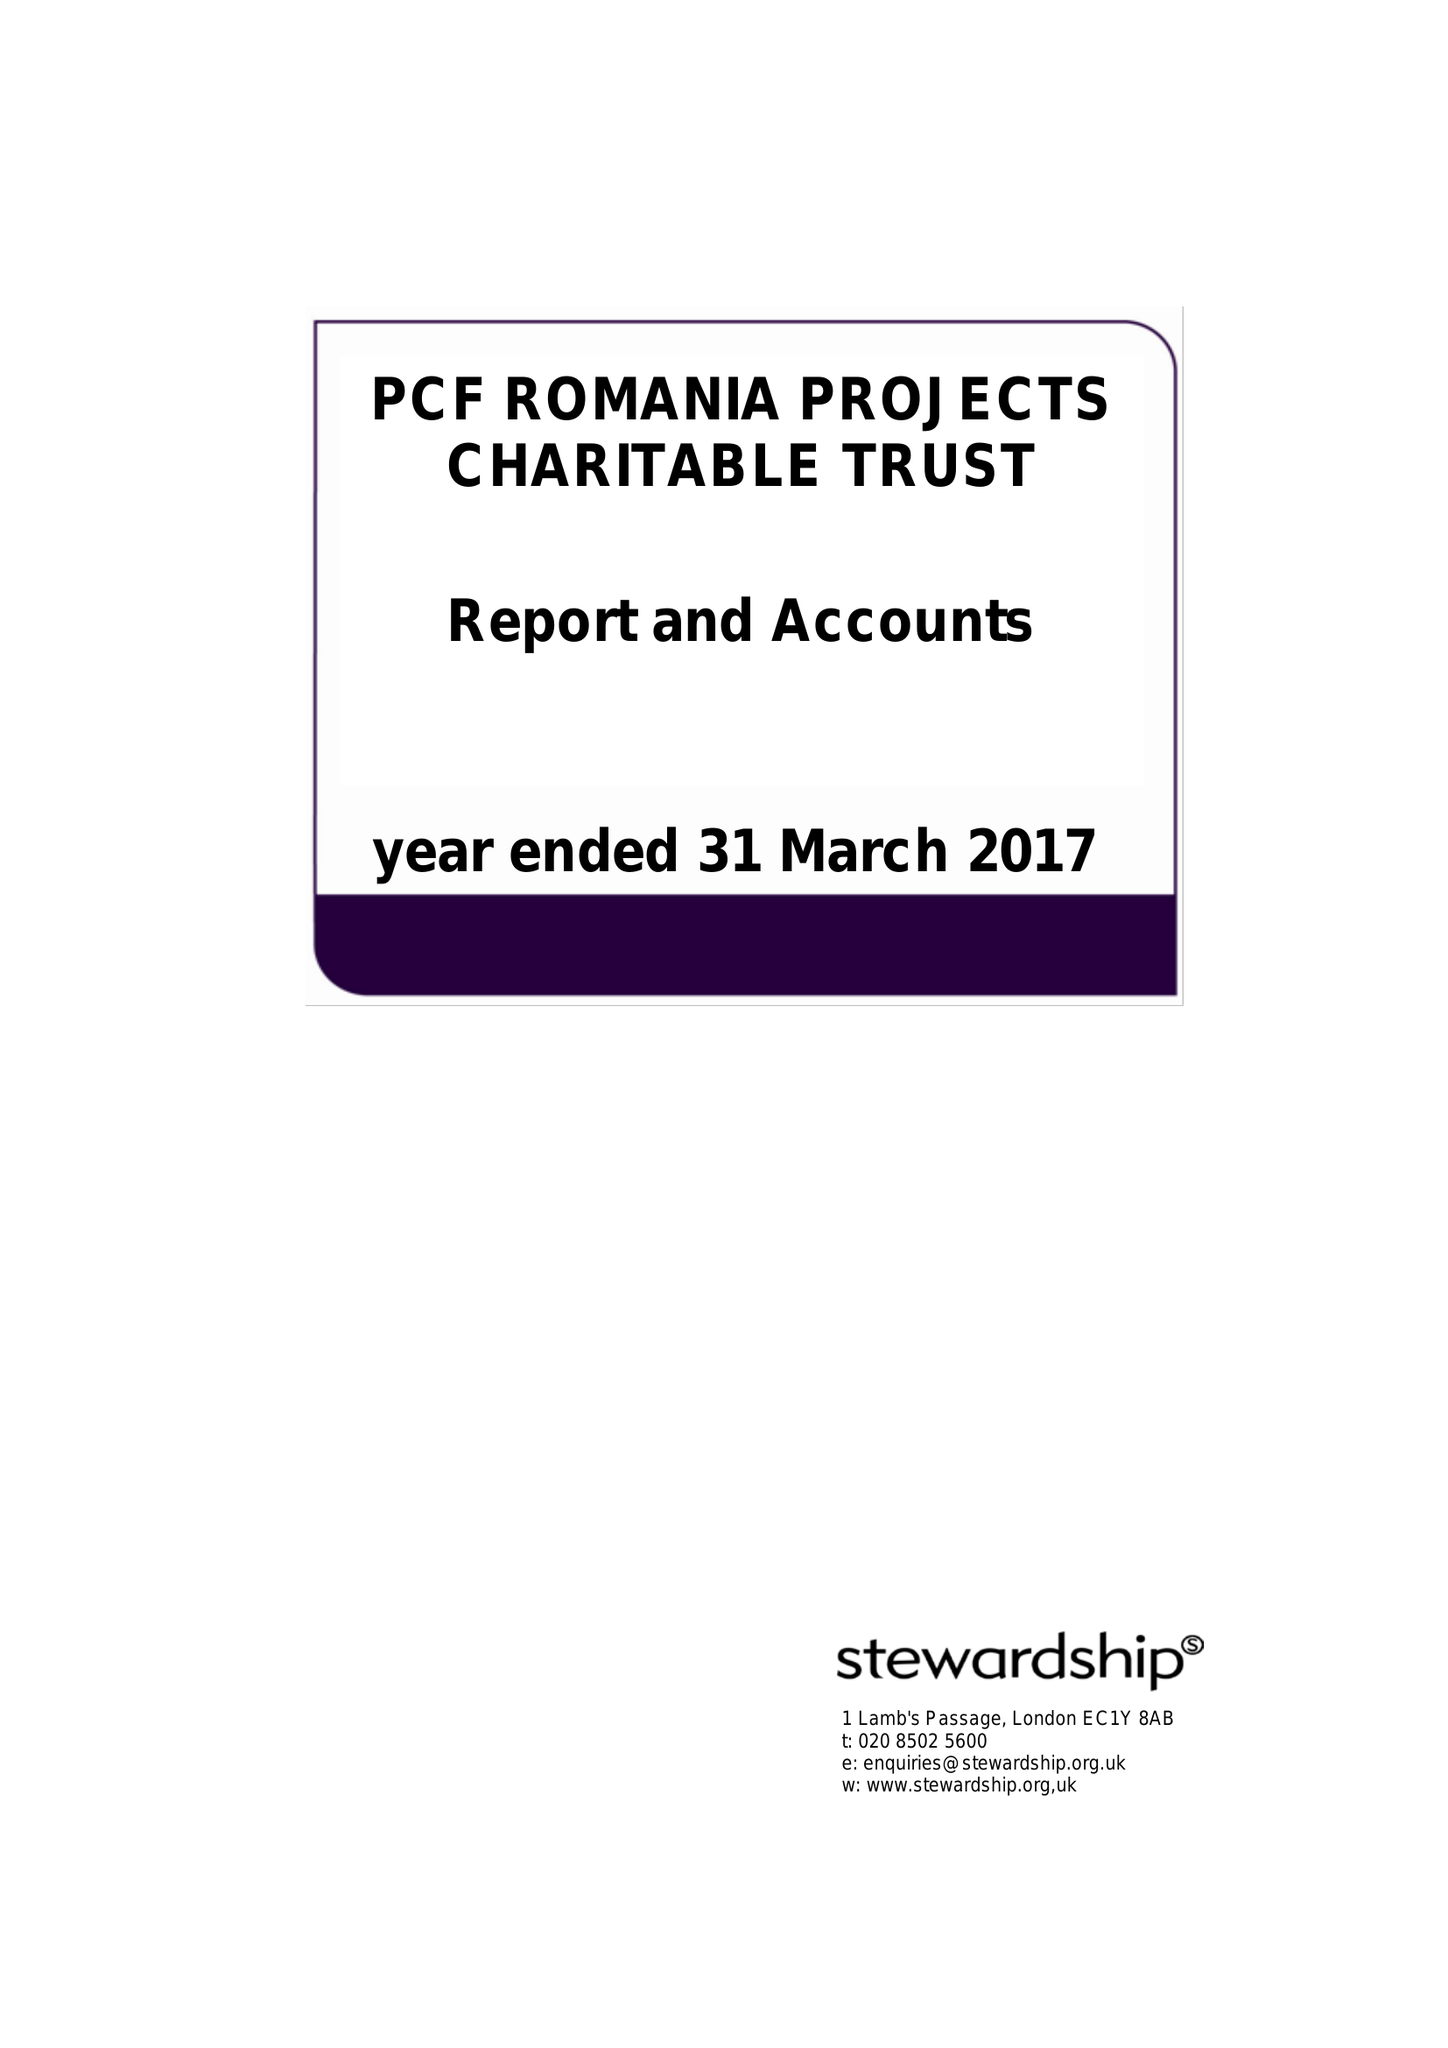What is the value for the report_date?
Answer the question using a single word or phrase. 2017-03-31 